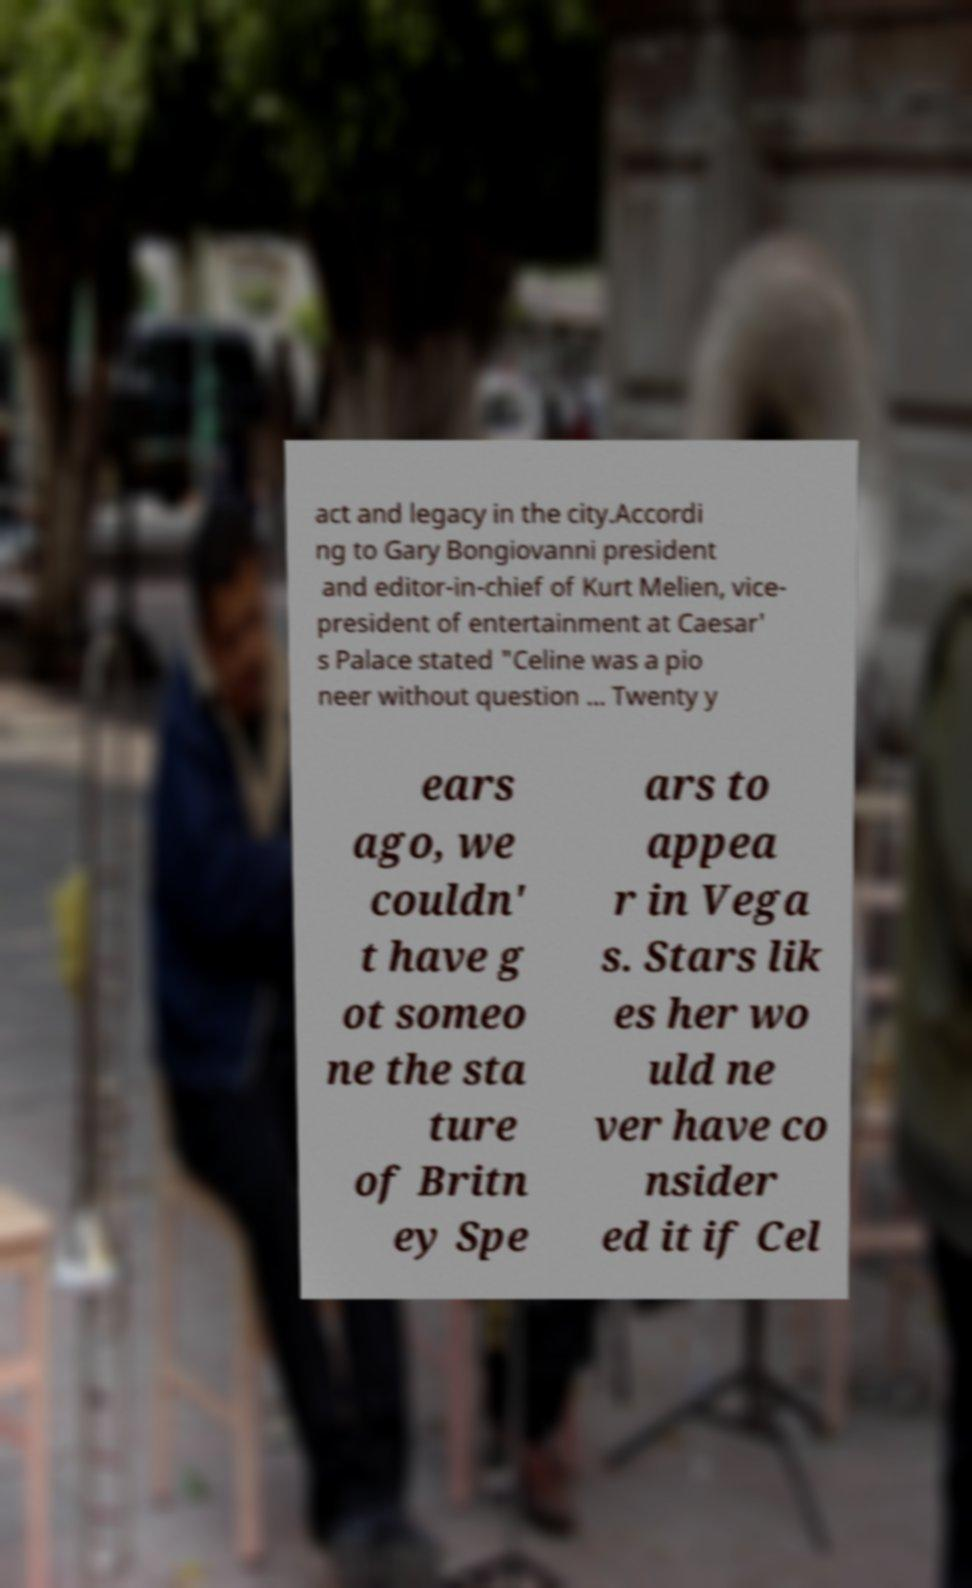There's text embedded in this image that I need extracted. Can you transcribe it verbatim? act and legacy in the city.Accordi ng to Gary Bongiovanni president and editor-in-chief of Kurt Melien, vice- president of entertainment at Caesar' s Palace stated "Celine was a pio neer without question ... Twenty y ears ago, we couldn' t have g ot someo ne the sta ture of Britn ey Spe ars to appea r in Vega s. Stars lik es her wo uld ne ver have co nsider ed it if Cel 